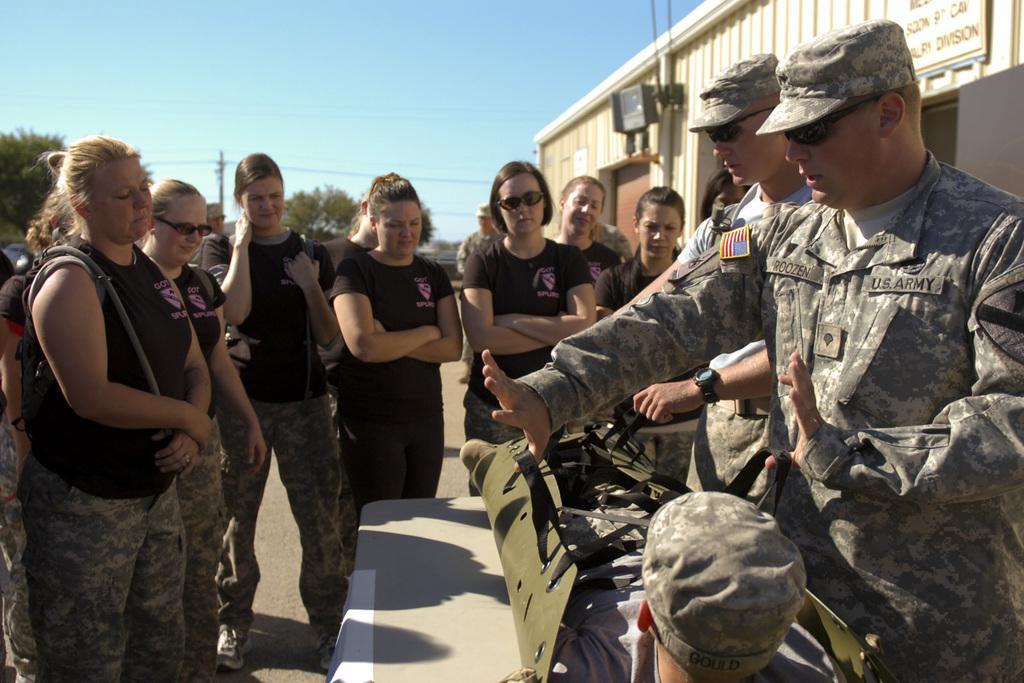Please provide a concise description of this image. On the right at the bottom we can see a man lying in a bag on a table and there are two men standing next to him. In the background there are few women standing on the road and on the right side there is a room,lights,poles,hoarding and we can also see trees,few other persons,trees,poles and sky. 